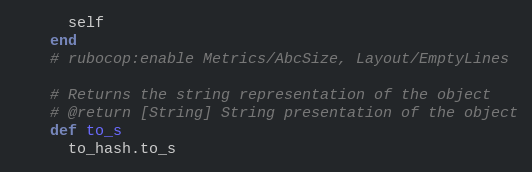Convert code to text. <code><loc_0><loc_0><loc_500><loc_500><_Ruby_>      self
    end
    # rubocop:enable Metrics/AbcSize, Layout/EmptyLines

    # Returns the string representation of the object
    # @return [String] String presentation of the object
    def to_s
      to_hash.to_s</code> 